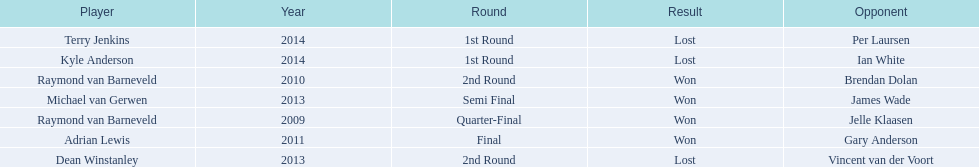What players competed in the pdc world darts championship? Raymond van Barneveld, Raymond van Barneveld, Adrian Lewis, Dean Winstanley, Michael van Gerwen, Terry Jenkins, Kyle Anderson. Of these players, who lost? Dean Winstanley, Terry Jenkins, Kyle Anderson. Which of these players lost in 2014? Terry Jenkins, Kyle Anderson. What are the players other than kyle anderson? Terry Jenkins. 